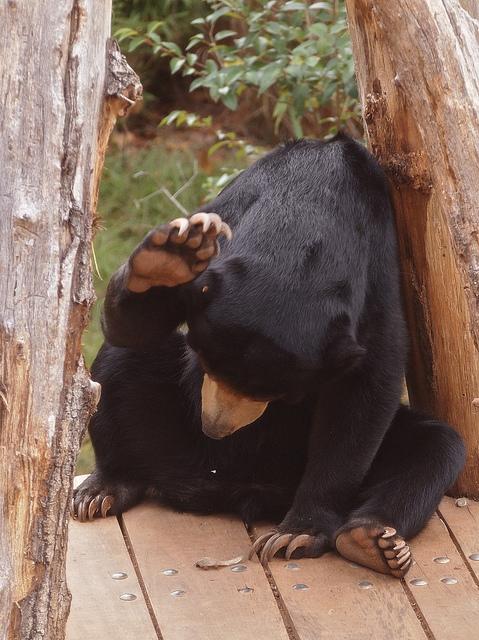Is the bear waving?
Answer briefly. Yes. Is this a white tiger?
Write a very short answer. No. Is the bear looking at the camera?
Answer briefly. No. 